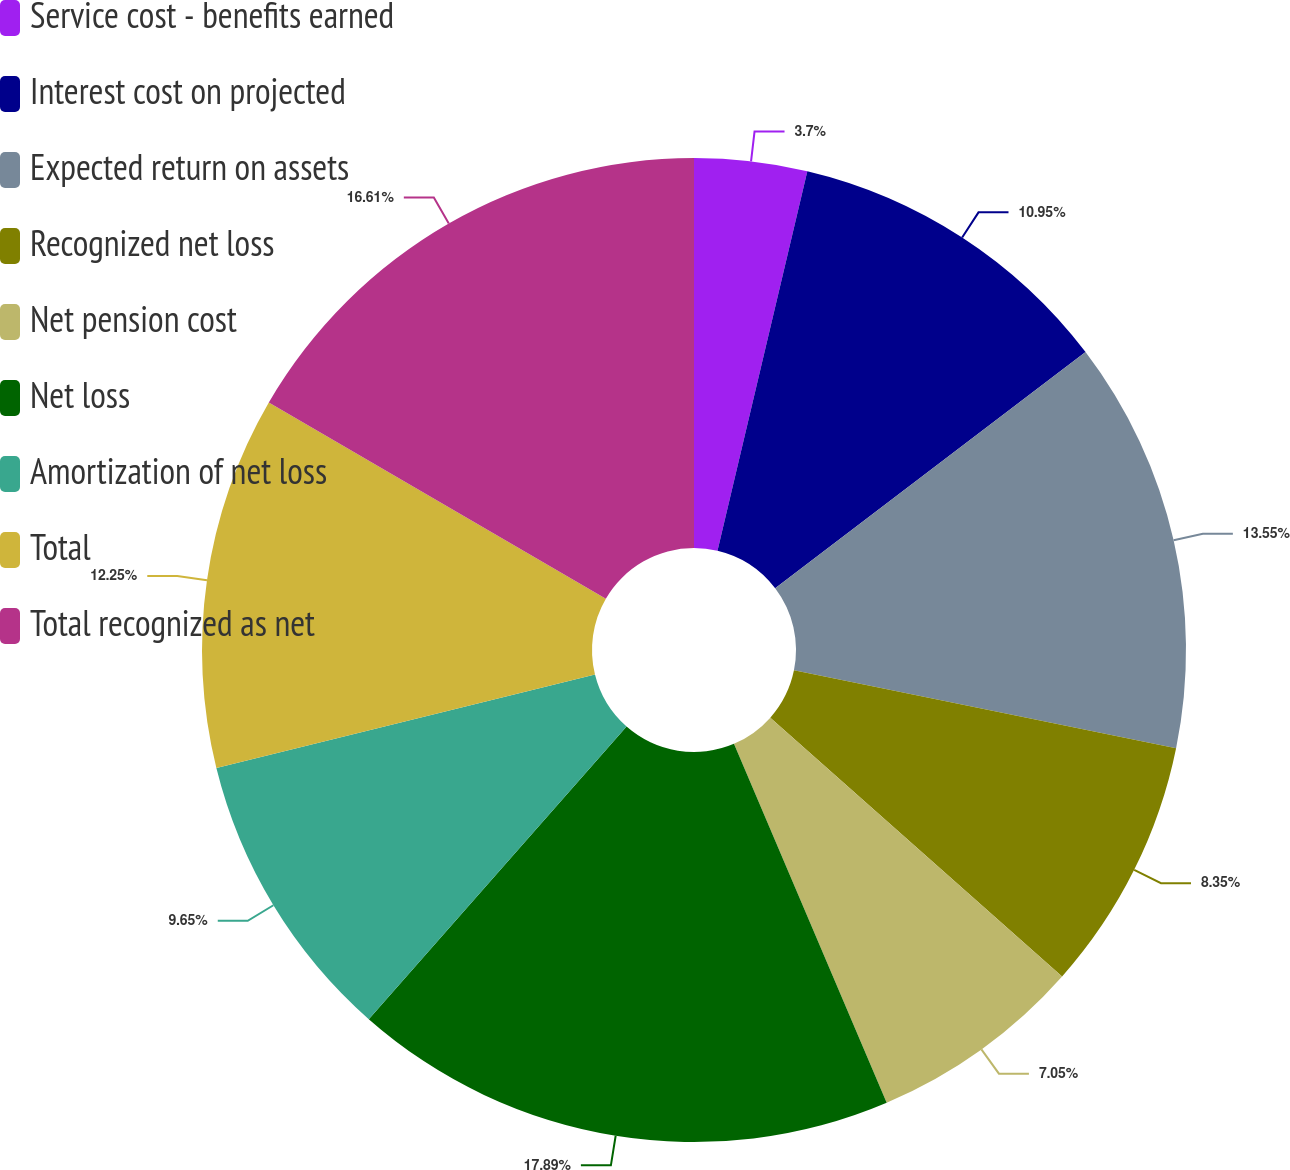Convert chart. <chart><loc_0><loc_0><loc_500><loc_500><pie_chart><fcel>Service cost - benefits earned<fcel>Interest cost on projected<fcel>Expected return on assets<fcel>Recognized net loss<fcel>Net pension cost<fcel>Net loss<fcel>Amortization of net loss<fcel>Total<fcel>Total recognized as net<nl><fcel>3.7%<fcel>10.95%<fcel>13.55%<fcel>8.35%<fcel>7.05%<fcel>17.9%<fcel>9.65%<fcel>12.25%<fcel>16.61%<nl></chart> 